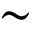Convert formula to latex. <formula><loc_0><loc_0><loc_500><loc_500>\sim</formula> 